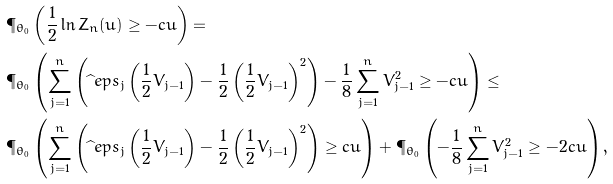<formula> <loc_0><loc_0><loc_500><loc_500>& \P _ { \theta _ { 0 } } \left ( \frac { 1 } { 2 } \ln Z _ { n } ( u ) \geq - c { u } \right ) = \\ & \P _ { \theta _ { 0 } } \left ( \sum _ { j = 1 } ^ { n } \left ( \widehat { \ } e p s _ { j } \left ( \frac { 1 } { 2 } V _ { j - 1 } \right ) - \frac { 1 } { 2 } \left ( \frac { 1 } { 2 } V _ { j - 1 } \right ) ^ { 2 } \right ) - \frac { 1 } { 8 } \sum _ { j = 1 } ^ { n } V ^ { 2 } _ { j - 1 } \geq - c { u } \right ) \leq \\ & \P _ { \theta _ { 0 } } \left ( \sum _ { j = 1 } ^ { n } \left ( \widehat { \ } e p s _ { j } \left ( \frac { 1 } { 2 } V _ { j - 1 } \right ) - \frac { 1 } { 2 } \left ( \frac { 1 } { 2 } V _ { j - 1 } \right ) ^ { 2 } \right ) \geq c { u } \right ) + \P _ { \theta _ { 0 } } \left ( - \frac { 1 } { 8 } \sum _ { j = 1 } ^ { n } V ^ { 2 } _ { j - 1 } \geq - 2 c { u } \right ) ,</formula> 